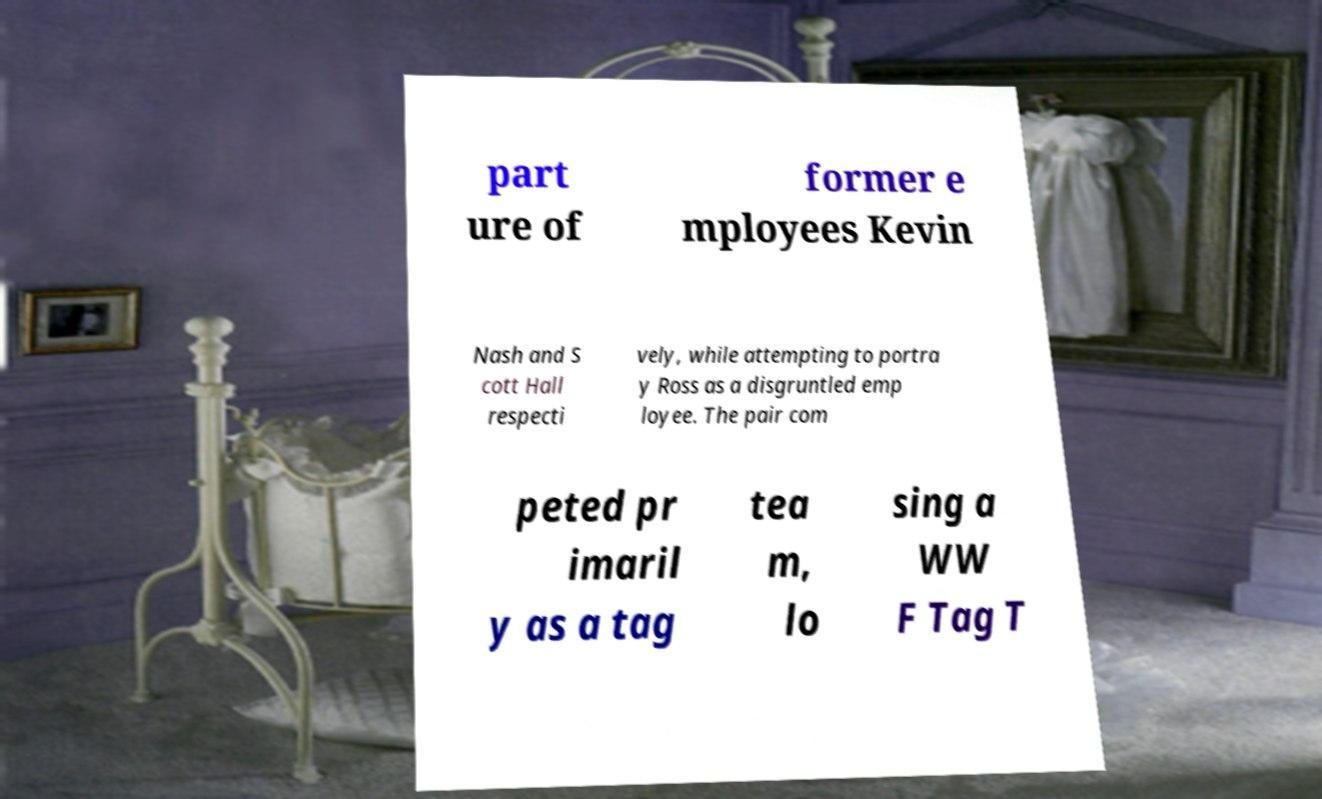Please identify and transcribe the text found in this image. part ure of former e mployees Kevin Nash and S cott Hall respecti vely, while attempting to portra y Ross as a disgruntled emp loyee. The pair com peted pr imaril y as a tag tea m, lo sing a WW F Tag T 